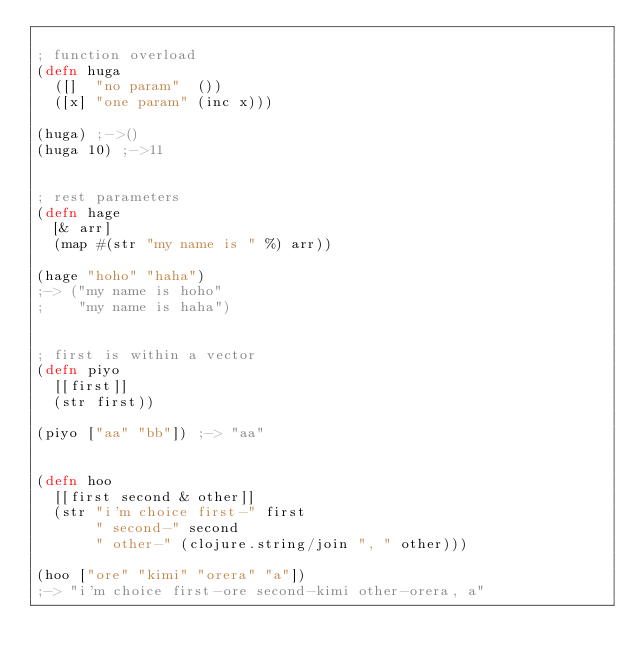Convert code to text. <code><loc_0><loc_0><loc_500><loc_500><_Clojure_>
; function overload
(defn huga
  ([]  "no param"  ())
  ([x] "one param" (inc x)))

(huga) ;->()
(huga 10) ;->11


; rest parameters
(defn hage
  [& arr]
  (map #(str "my name is " %) arr))

(hage "hoho" "haha")
;-> ("my name is hoho"
;    "my name is haha")


; first is within a vector
(defn piyo
  [[first]]
  (str first))

(piyo ["aa" "bb"]) ;-> "aa"


(defn hoo
  [[first second & other]]
  (str "i'm choice first-" first
       " second-" second
       " other-" (clojure.string/join ", " other)))

(hoo ["ore" "kimi" "orera" "a"])
;-> "i'm choice first-ore second-kimi other-orera, a"
</code> 